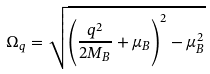<formula> <loc_0><loc_0><loc_500><loc_500>\Omega _ { q } = \sqrt { \left ( \frac { { q } ^ { 2 } } { 2 M _ { B } } + \mu _ { B } \right ) ^ { 2 } - \mu _ { B } ^ { 2 } }</formula> 